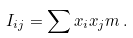Convert formula to latex. <formula><loc_0><loc_0><loc_500><loc_500>I _ { i j } = \sum x _ { i } x _ { j } m \, .</formula> 